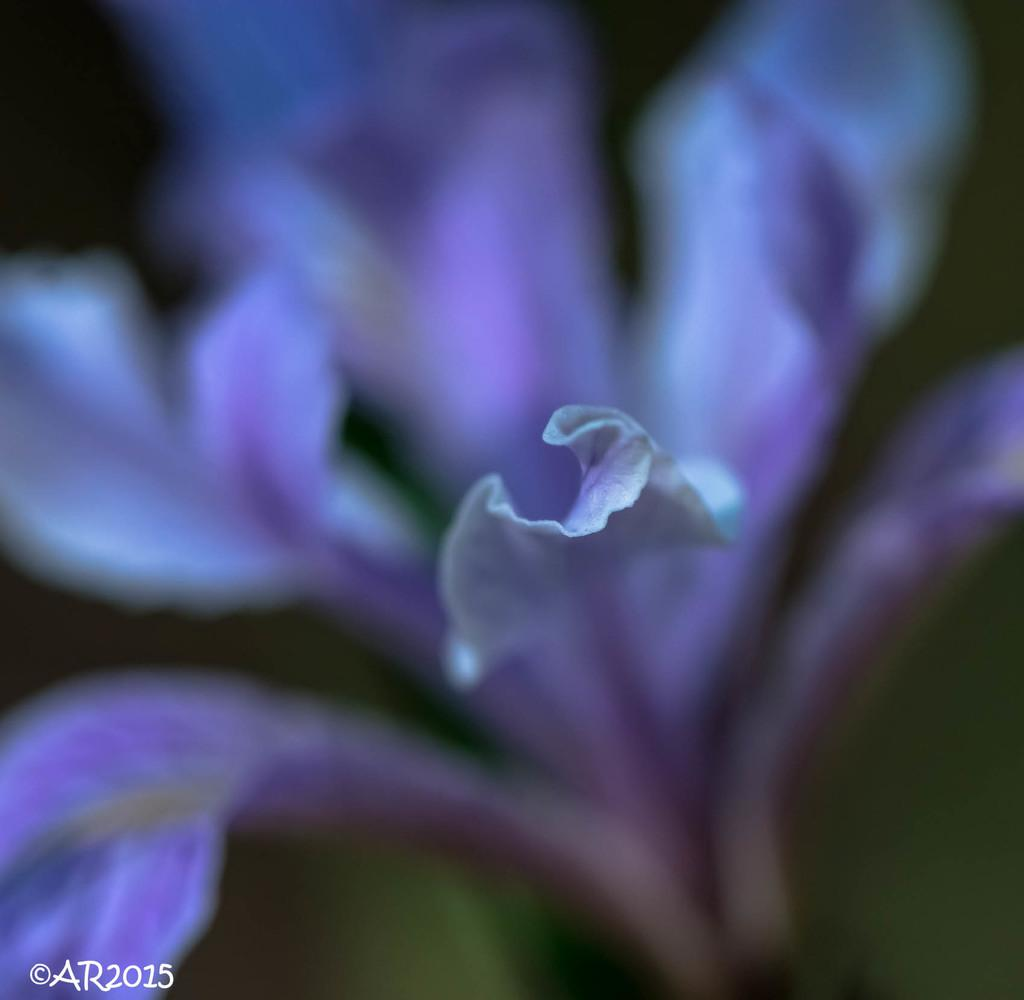What is the main subject of the image? The main subject of the image is a flower. What is the history of the pet that belongs to the flower in the image? There is no pet mentioned in the image, and the flower does not have a history of belonging to a pet. 